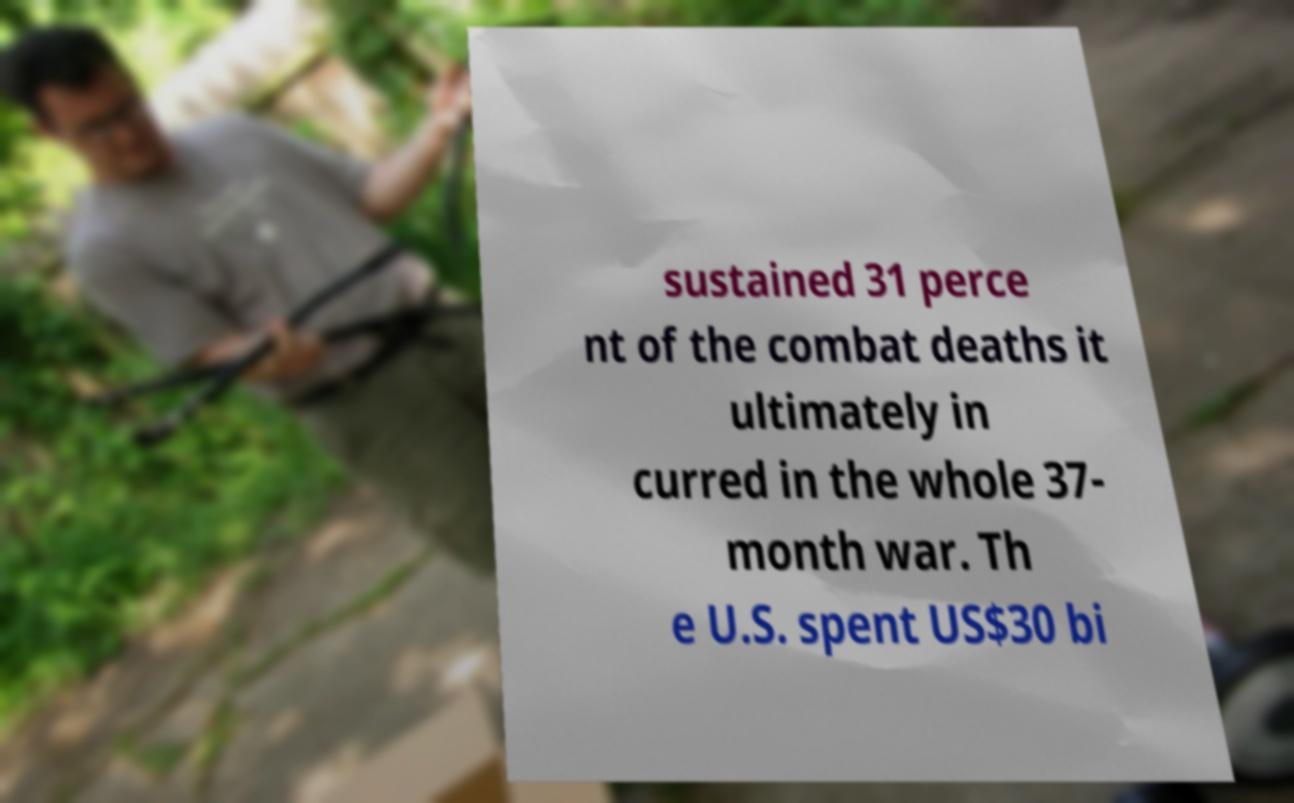What messages or text are displayed in this image? I need them in a readable, typed format. sustained 31 perce nt of the combat deaths it ultimately in curred in the whole 37- month war. Th e U.S. spent US$30 bi 